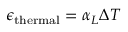<formula> <loc_0><loc_0><loc_500><loc_500>\epsilon _ { t h e r m a l } = \alpha _ { L } \Delta T</formula> 